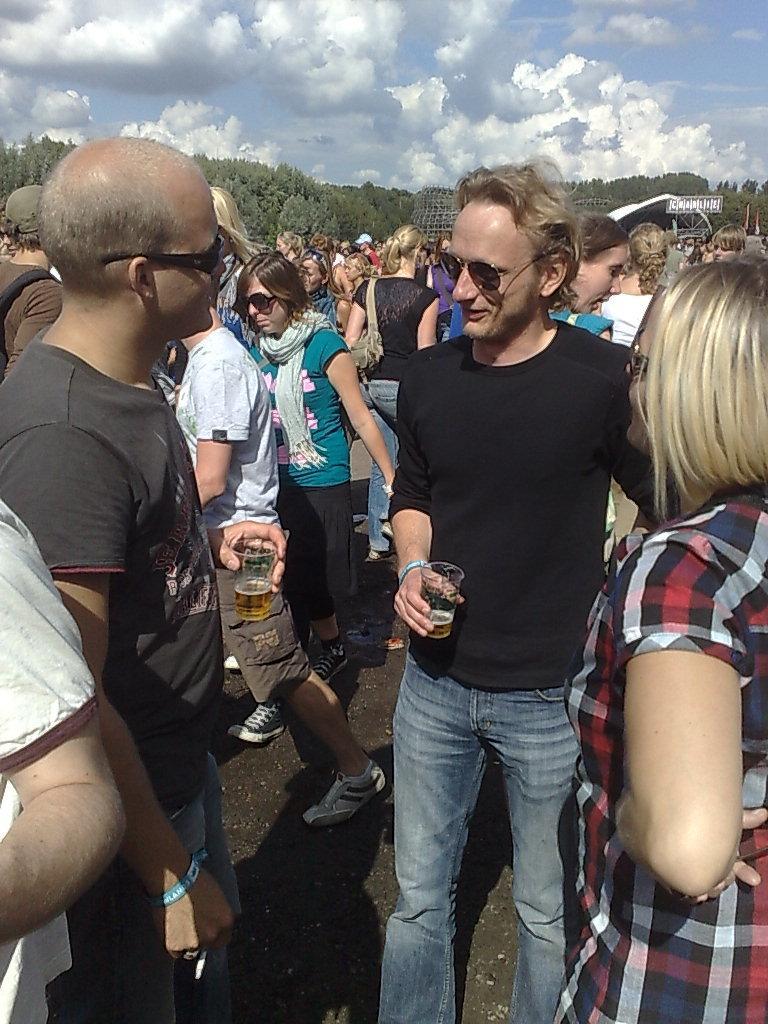Could you give a brief overview of what you see in this image? In the center of the image we can see group of people are there, some of them are wearing bag and holding glass. In the background of the image we can see trees, shed, flag. At the top of the image clouds are present in the sky. At the bottom of the image there is a ground. 